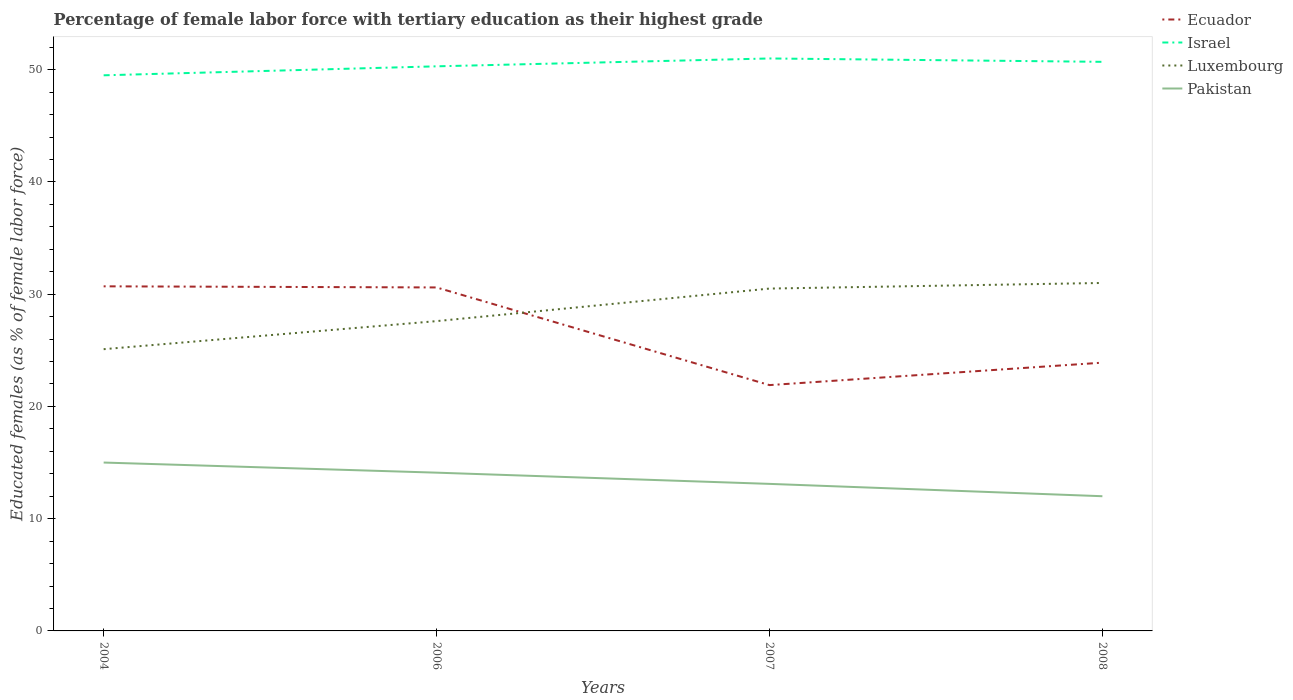Does the line corresponding to Ecuador intersect with the line corresponding to Israel?
Offer a very short reply. No. Is the number of lines equal to the number of legend labels?
Make the answer very short. Yes. Across all years, what is the maximum percentage of female labor force with tertiary education in Ecuador?
Provide a succinct answer. 21.9. In which year was the percentage of female labor force with tertiary education in Luxembourg maximum?
Provide a succinct answer. 2004. What is the total percentage of female labor force with tertiary education in Israel in the graph?
Ensure brevity in your answer.  -0.7. Is the percentage of female labor force with tertiary education in Israel strictly greater than the percentage of female labor force with tertiary education in Luxembourg over the years?
Ensure brevity in your answer.  No. What is the difference between two consecutive major ticks on the Y-axis?
Your answer should be compact. 10. Are the values on the major ticks of Y-axis written in scientific E-notation?
Offer a very short reply. No. Does the graph contain any zero values?
Offer a terse response. No. Does the graph contain grids?
Your response must be concise. No. Where does the legend appear in the graph?
Ensure brevity in your answer.  Top right. How are the legend labels stacked?
Ensure brevity in your answer.  Vertical. What is the title of the graph?
Keep it short and to the point. Percentage of female labor force with tertiary education as their highest grade. What is the label or title of the X-axis?
Ensure brevity in your answer.  Years. What is the label or title of the Y-axis?
Make the answer very short. Educated females (as % of female labor force). What is the Educated females (as % of female labor force) of Ecuador in 2004?
Your answer should be very brief. 30.7. What is the Educated females (as % of female labor force) of Israel in 2004?
Your answer should be compact. 49.5. What is the Educated females (as % of female labor force) in Luxembourg in 2004?
Make the answer very short. 25.1. What is the Educated females (as % of female labor force) of Ecuador in 2006?
Ensure brevity in your answer.  30.6. What is the Educated females (as % of female labor force) in Israel in 2006?
Your answer should be very brief. 50.3. What is the Educated females (as % of female labor force) in Luxembourg in 2006?
Your answer should be compact. 27.6. What is the Educated females (as % of female labor force) of Pakistan in 2006?
Make the answer very short. 14.1. What is the Educated females (as % of female labor force) of Ecuador in 2007?
Your answer should be compact. 21.9. What is the Educated females (as % of female labor force) in Luxembourg in 2007?
Your answer should be compact. 30.5. What is the Educated females (as % of female labor force) of Pakistan in 2007?
Offer a very short reply. 13.1. What is the Educated females (as % of female labor force) of Ecuador in 2008?
Make the answer very short. 23.9. What is the Educated females (as % of female labor force) in Israel in 2008?
Offer a very short reply. 50.7. Across all years, what is the maximum Educated females (as % of female labor force) in Ecuador?
Provide a short and direct response. 30.7. Across all years, what is the maximum Educated females (as % of female labor force) of Israel?
Offer a very short reply. 51. Across all years, what is the minimum Educated females (as % of female labor force) of Ecuador?
Provide a short and direct response. 21.9. Across all years, what is the minimum Educated females (as % of female labor force) in Israel?
Offer a very short reply. 49.5. Across all years, what is the minimum Educated females (as % of female labor force) in Luxembourg?
Give a very brief answer. 25.1. Across all years, what is the minimum Educated females (as % of female labor force) in Pakistan?
Your answer should be very brief. 12. What is the total Educated females (as % of female labor force) of Ecuador in the graph?
Your answer should be very brief. 107.1. What is the total Educated females (as % of female labor force) of Israel in the graph?
Offer a very short reply. 201.5. What is the total Educated females (as % of female labor force) in Luxembourg in the graph?
Offer a terse response. 114.2. What is the total Educated females (as % of female labor force) of Pakistan in the graph?
Offer a very short reply. 54.2. What is the difference between the Educated females (as % of female labor force) of Ecuador in 2004 and that in 2006?
Provide a short and direct response. 0.1. What is the difference between the Educated females (as % of female labor force) in Pakistan in 2004 and that in 2006?
Give a very brief answer. 0.9. What is the difference between the Educated females (as % of female labor force) of Ecuador in 2004 and that in 2007?
Your answer should be compact. 8.8. What is the difference between the Educated females (as % of female labor force) of Israel in 2004 and that in 2007?
Give a very brief answer. -1.5. What is the difference between the Educated females (as % of female labor force) in Pakistan in 2004 and that in 2007?
Give a very brief answer. 1.9. What is the difference between the Educated females (as % of female labor force) in Ecuador in 2004 and that in 2008?
Offer a very short reply. 6.8. What is the difference between the Educated females (as % of female labor force) of Israel in 2004 and that in 2008?
Your response must be concise. -1.2. What is the difference between the Educated females (as % of female labor force) of Luxembourg in 2004 and that in 2008?
Your response must be concise. -5.9. What is the difference between the Educated females (as % of female labor force) in Pakistan in 2004 and that in 2008?
Your answer should be very brief. 3. What is the difference between the Educated females (as % of female labor force) in Ecuador in 2006 and that in 2007?
Ensure brevity in your answer.  8.7. What is the difference between the Educated females (as % of female labor force) of Israel in 2006 and that in 2007?
Keep it short and to the point. -0.7. What is the difference between the Educated females (as % of female labor force) in Pakistan in 2006 and that in 2007?
Your answer should be very brief. 1. What is the difference between the Educated females (as % of female labor force) of Ecuador in 2006 and that in 2008?
Your answer should be compact. 6.7. What is the difference between the Educated females (as % of female labor force) in Israel in 2006 and that in 2008?
Offer a terse response. -0.4. What is the difference between the Educated females (as % of female labor force) in Luxembourg in 2006 and that in 2008?
Provide a short and direct response. -3.4. What is the difference between the Educated females (as % of female labor force) of Luxembourg in 2007 and that in 2008?
Ensure brevity in your answer.  -0.5. What is the difference between the Educated females (as % of female labor force) in Pakistan in 2007 and that in 2008?
Keep it short and to the point. 1.1. What is the difference between the Educated females (as % of female labor force) of Ecuador in 2004 and the Educated females (as % of female labor force) of Israel in 2006?
Make the answer very short. -19.6. What is the difference between the Educated females (as % of female labor force) of Ecuador in 2004 and the Educated females (as % of female labor force) of Pakistan in 2006?
Offer a terse response. 16.6. What is the difference between the Educated females (as % of female labor force) in Israel in 2004 and the Educated females (as % of female labor force) in Luxembourg in 2006?
Keep it short and to the point. 21.9. What is the difference between the Educated females (as % of female labor force) in Israel in 2004 and the Educated females (as % of female labor force) in Pakistan in 2006?
Provide a succinct answer. 35.4. What is the difference between the Educated females (as % of female labor force) of Ecuador in 2004 and the Educated females (as % of female labor force) of Israel in 2007?
Give a very brief answer. -20.3. What is the difference between the Educated females (as % of female labor force) in Ecuador in 2004 and the Educated females (as % of female labor force) in Luxembourg in 2007?
Keep it short and to the point. 0.2. What is the difference between the Educated females (as % of female labor force) of Ecuador in 2004 and the Educated females (as % of female labor force) of Pakistan in 2007?
Your answer should be compact. 17.6. What is the difference between the Educated females (as % of female labor force) of Israel in 2004 and the Educated females (as % of female labor force) of Pakistan in 2007?
Offer a terse response. 36.4. What is the difference between the Educated females (as % of female labor force) in Ecuador in 2004 and the Educated females (as % of female labor force) in Israel in 2008?
Give a very brief answer. -20. What is the difference between the Educated females (as % of female labor force) of Ecuador in 2004 and the Educated females (as % of female labor force) of Luxembourg in 2008?
Offer a terse response. -0.3. What is the difference between the Educated females (as % of female labor force) of Israel in 2004 and the Educated females (as % of female labor force) of Luxembourg in 2008?
Provide a succinct answer. 18.5. What is the difference between the Educated females (as % of female labor force) of Israel in 2004 and the Educated females (as % of female labor force) of Pakistan in 2008?
Your response must be concise. 37.5. What is the difference between the Educated females (as % of female labor force) of Luxembourg in 2004 and the Educated females (as % of female labor force) of Pakistan in 2008?
Make the answer very short. 13.1. What is the difference between the Educated females (as % of female labor force) in Ecuador in 2006 and the Educated females (as % of female labor force) in Israel in 2007?
Provide a succinct answer. -20.4. What is the difference between the Educated females (as % of female labor force) in Israel in 2006 and the Educated females (as % of female labor force) in Luxembourg in 2007?
Give a very brief answer. 19.8. What is the difference between the Educated females (as % of female labor force) of Israel in 2006 and the Educated females (as % of female labor force) of Pakistan in 2007?
Give a very brief answer. 37.2. What is the difference between the Educated females (as % of female labor force) of Ecuador in 2006 and the Educated females (as % of female labor force) of Israel in 2008?
Offer a terse response. -20.1. What is the difference between the Educated females (as % of female labor force) of Ecuador in 2006 and the Educated females (as % of female labor force) of Luxembourg in 2008?
Offer a terse response. -0.4. What is the difference between the Educated females (as % of female labor force) in Ecuador in 2006 and the Educated females (as % of female labor force) in Pakistan in 2008?
Your answer should be compact. 18.6. What is the difference between the Educated females (as % of female labor force) of Israel in 2006 and the Educated females (as % of female labor force) of Luxembourg in 2008?
Your answer should be compact. 19.3. What is the difference between the Educated females (as % of female labor force) in Israel in 2006 and the Educated females (as % of female labor force) in Pakistan in 2008?
Keep it short and to the point. 38.3. What is the difference between the Educated females (as % of female labor force) of Ecuador in 2007 and the Educated females (as % of female labor force) of Israel in 2008?
Your answer should be compact. -28.8. What is the difference between the Educated females (as % of female labor force) in Ecuador in 2007 and the Educated females (as % of female labor force) in Luxembourg in 2008?
Keep it short and to the point. -9.1. What is the difference between the Educated females (as % of female labor force) in Israel in 2007 and the Educated females (as % of female labor force) in Luxembourg in 2008?
Your answer should be compact. 20. What is the difference between the Educated females (as % of female labor force) in Israel in 2007 and the Educated females (as % of female labor force) in Pakistan in 2008?
Offer a terse response. 39. What is the average Educated females (as % of female labor force) of Ecuador per year?
Your response must be concise. 26.77. What is the average Educated females (as % of female labor force) of Israel per year?
Provide a short and direct response. 50.38. What is the average Educated females (as % of female labor force) of Luxembourg per year?
Make the answer very short. 28.55. What is the average Educated females (as % of female labor force) of Pakistan per year?
Make the answer very short. 13.55. In the year 2004, what is the difference between the Educated females (as % of female labor force) of Ecuador and Educated females (as % of female labor force) of Israel?
Ensure brevity in your answer.  -18.8. In the year 2004, what is the difference between the Educated females (as % of female labor force) in Ecuador and Educated females (as % of female labor force) in Luxembourg?
Provide a short and direct response. 5.6. In the year 2004, what is the difference between the Educated females (as % of female labor force) in Ecuador and Educated females (as % of female labor force) in Pakistan?
Keep it short and to the point. 15.7. In the year 2004, what is the difference between the Educated females (as % of female labor force) of Israel and Educated females (as % of female labor force) of Luxembourg?
Give a very brief answer. 24.4. In the year 2004, what is the difference between the Educated females (as % of female labor force) of Israel and Educated females (as % of female labor force) of Pakistan?
Keep it short and to the point. 34.5. In the year 2004, what is the difference between the Educated females (as % of female labor force) of Luxembourg and Educated females (as % of female labor force) of Pakistan?
Keep it short and to the point. 10.1. In the year 2006, what is the difference between the Educated females (as % of female labor force) of Ecuador and Educated females (as % of female labor force) of Israel?
Ensure brevity in your answer.  -19.7. In the year 2006, what is the difference between the Educated females (as % of female labor force) in Israel and Educated females (as % of female labor force) in Luxembourg?
Your answer should be very brief. 22.7. In the year 2006, what is the difference between the Educated females (as % of female labor force) of Israel and Educated females (as % of female labor force) of Pakistan?
Keep it short and to the point. 36.2. In the year 2007, what is the difference between the Educated females (as % of female labor force) of Ecuador and Educated females (as % of female labor force) of Israel?
Offer a terse response. -29.1. In the year 2007, what is the difference between the Educated females (as % of female labor force) of Ecuador and Educated females (as % of female labor force) of Luxembourg?
Provide a short and direct response. -8.6. In the year 2007, what is the difference between the Educated females (as % of female labor force) of Israel and Educated females (as % of female labor force) of Pakistan?
Your answer should be compact. 37.9. In the year 2007, what is the difference between the Educated females (as % of female labor force) in Luxembourg and Educated females (as % of female labor force) in Pakistan?
Provide a succinct answer. 17.4. In the year 2008, what is the difference between the Educated females (as % of female labor force) of Ecuador and Educated females (as % of female labor force) of Israel?
Keep it short and to the point. -26.8. In the year 2008, what is the difference between the Educated females (as % of female labor force) of Ecuador and Educated females (as % of female labor force) of Luxembourg?
Make the answer very short. -7.1. In the year 2008, what is the difference between the Educated females (as % of female labor force) in Ecuador and Educated females (as % of female labor force) in Pakistan?
Provide a short and direct response. 11.9. In the year 2008, what is the difference between the Educated females (as % of female labor force) in Israel and Educated females (as % of female labor force) in Luxembourg?
Keep it short and to the point. 19.7. In the year 2008, what is the difference between the Educated females (as % of female labor force) of Israel and Educated females (as % of female labor force) of Pakistan?
Keep it short and to the point. 38.7. What is the ratio of the Educated females (as % of female labor force) in Ecuador in 2004 to that in 2006?
Your response must be concise. 1. What is the ratio of the Educated females (as % of female labor force) of Israel in 2004 to that in 2006?
Offer a very short reply. 0.98. What is the ratio of the Educated females (as % of female labor force) of Luxembourg in 2004 to that in 2006?
Ensure brevity in your answer.  0.91. What is the ratio of the Educated females (as % of female labor force) of Pakistan in 2004 to that in 2006?
Ensure brevity in your answer.  1.06. What is the ratio of the Educated females (as % of female labor force) of Ecuador in 2004 to that in 2007?
Your answer should be compact. 1.4. What is the ratio of the Educated females (as % of female labor force) in Israel in 2004 to that in 2007?
Offer a terse response. 0.97. What is the ratio of the Educated females (as % of female labor force) in Luxembourg in 2004 to that in 2007?
Make the answer very short. 0.82. What is the ratio of the Educated females (as % of female labor force) in Pakistan in 2004 to that in 2007?
Offer a terse response. 1.15. What is the ratio of the Educated females (as % of female labor force) in Ecuador in 2004 to that in 2008?
Provide a short and direct response. 1.28. What is the ratio of the Educated females (as % of female labor force) in Israel in 2004 to that in 2008?
Provide a short and direct response. 0.98. What is the ratio of the Educated females (as % of female labor force) in Luxembourg in 2004 to that in 2008?
Your answer should be very brief. 0.81. What is the ratio of the Educated females (as % of female labor force) in Pakistan in 2004 to that in 2008?
Keep it short and to the point. 1.25. What is the ratio of the Educated females (as % of female labor force) in Ecuador in 2006 to that in 2007?
Keep it short and to the point. 1.4. What is the ratio of the Educated females (as % of female labor force) in Israel in 2006 to that in 2007?
Provide a short and direct response. 0.99. What is the ratio of the Educated females (as % of female labor force) of Luxembourg in 2006 to that in 2007?
Your answer should be compact. 0.9. What is the ratio of the Educated females (as % of female labor force) in Pakistan in 2006 to that in 2007?
Provide a short and direct response. 1.08. What is the ratio of the Educated females (as % of female labor force) in Ecuador in 2006 to that in 2008?
Ensure brevity in your answer.  1.28. What is the ratio of the Educated females (as % of female labor force) in Luxembourg in 2006 to that in 2008?
Ensure brevity in your answer.  0.89. What is the ratio of the Educated females (as % of female labor force) in Pakistan in 2006 to that in 2008?
Your response must be concise. 1.18. What is the ratio of the Educated females (as % of female labor force) of Ecuador in 2007 to that in 2008?
Offer a very short reply. 0.92. What is the ratio of the Educated females (as % of female labor force) in Israel in 2007 to that in 2008?
Ensure brevity in your answer.  1.01. What is the ratio of the Educated females (as % of female labor force) of Luxembourg in 2007 to that in 2008?
Offer a terse response. 0.98. What is the ratio of the Educated females (as % of female labor force) in Pakistan in 2007 to that in 2008?
Make the answer very short. 1.09. What is the difference between the highest and the second highest Educated females (as % of female labor force) in Ecuador?
Your response must be concise. 0.1. What is the difference between the highest and the second highest Educated females (as % of female labor force) in Israel?
Provide a short and direct response. 0.3. What is the difference between the highest and the second highest Educated females (as % of female labor force) in Pakistan?
Provide a succinct answer. 0.9. What is the difference between the highest and the lowest Educated females (as % of female labor force) in Israel?
Offer a very short reply. 1.5. What is the difference between the highest and the lowest Educated females (as % of female labor force) in Pakistan?
Ensure brevity in your answer.  3. 